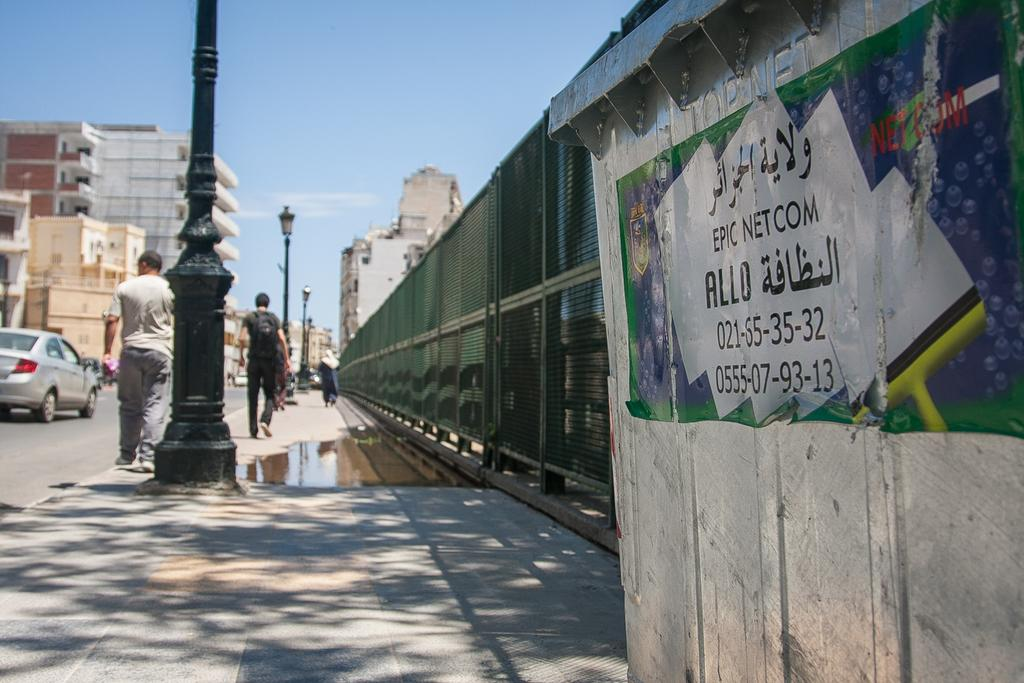<image>
Describe the image concisely. A city street with an advertisement for Netcom painted on a wall 